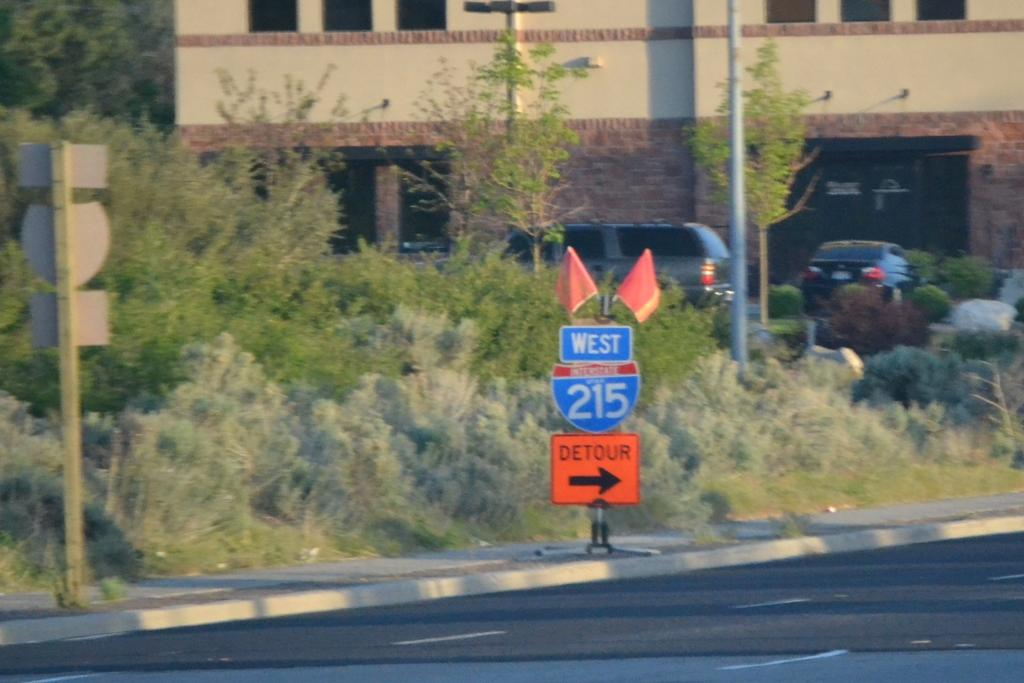<image>
Give a short and clear explanation of the subsequent image. A road sign showing that there is a detour for highway 215 West. 